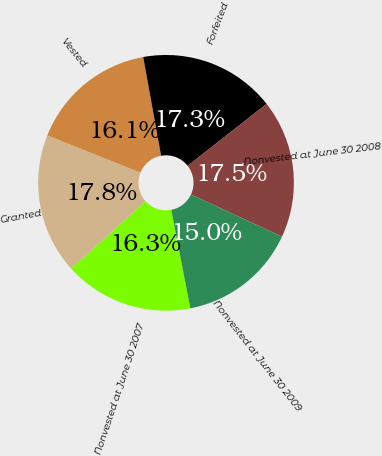<chart> <loc_0><loc_0><loc_500><loc_500><pie_chart><fcel>Nonvested at June 30 2007<fcel>Granted<fcel>Vested<fcel>Forfeited<fcel>Nonvested at June 30 2008<fcel>Nonvested at June 30 2009<nl><fcel>16.34%<fcel>17.76%<fcel>16.09%<fcel>17.26%<fcel>17.51%<fcel>15.03%<nl></chart> 